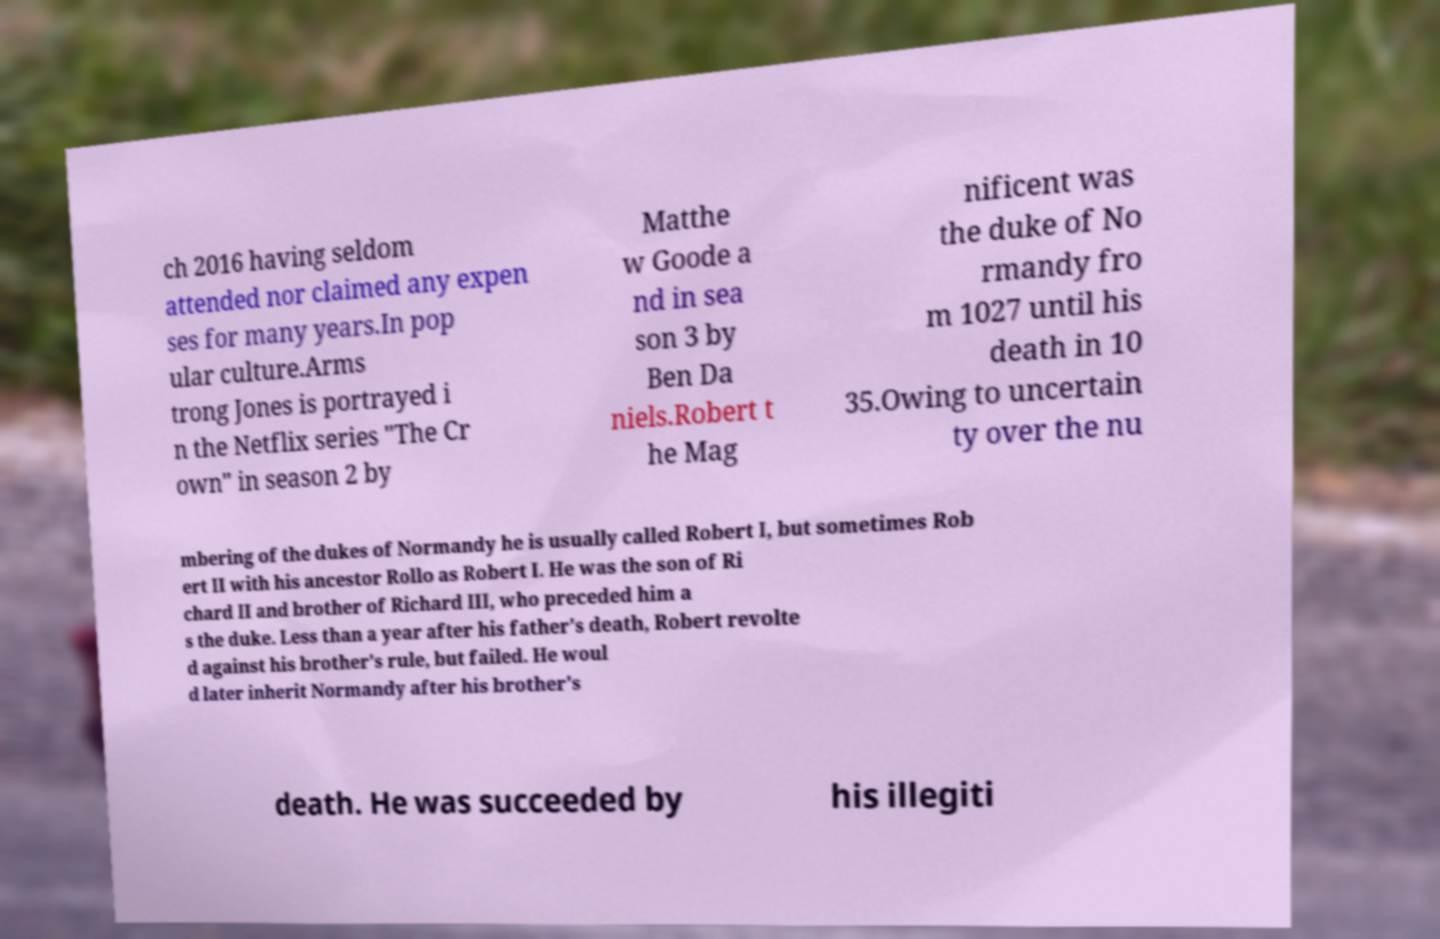Could you extract and type out the text from this image? ch 2016 having seldom attended nor claimed any expen ses for many years.In pop ular culture.Arms trong Jones is portrayed i n the Netflix series "The Cr own" in season 2 by Matthe w Goode a nd in sea son 3 by Ben Da niels.Robert t he Mag nificent was the duke of No rmandy fro m 1027 until his death in 10 35.Owing to uncertain ty over the nu mbering of the dukes of Normandy he is usually called Robert I, but sometimes Rob ert II with his ancestor Rollo as Robert I. He was the son of Ri chard II and brother of Richard III, who preceded him a s the duke. Less than a year after his father's death, Robert revolte d against his brother's rule, but failed. He woul d later inherit Normandy after his brother's death. He was succeeded by his illegiti 